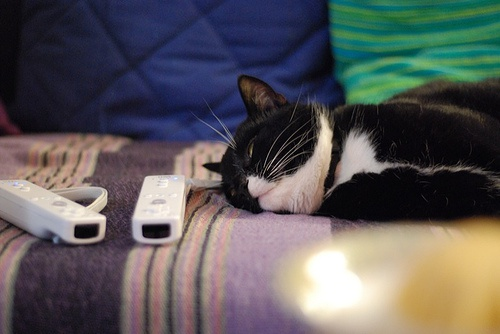Describe the objects in this image and their specific colors. I can see couch in black, gray, and darkgray tones, cat in black, gray, and darkgray tones, remote in black, darkgray, and lightgray tones, and remote in black, lightgray, darkgray, and gray tones in this image. 